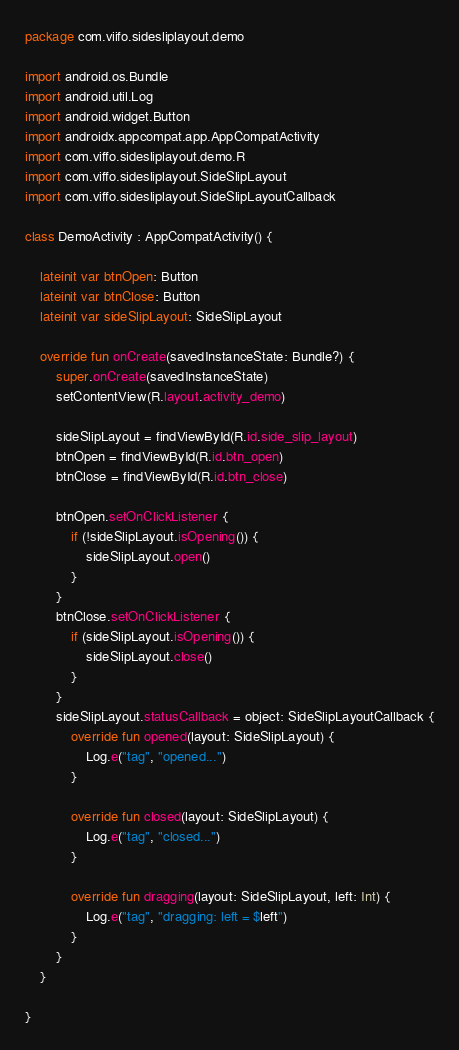<code> <loc_0><loc_0><loc_500><loc_500><_Kotlin_>package com.viifo.sidesliplayout.demo

import android.os.Bundle
import android.util.Log
import android.widget.Button
import androidx.appcompat.app.AppCompatActivity
import com.viffo.sidesliplayout.demo.R
import com.viffo.sidesliplayout.SideSlipLayout
import com.viffo.sidesliplayout.SideSlipLayoutCallback

class DemoActivity : AppCompatActivity() {

    lateinit var btnOpen: Button
    lateinit var btnClose: Button
    lateinit var sideSlipLayout: SideSlipLayout

    override fun onCreate(savedInstanceState: Bundle?) {
        super.onCreate(savedInstanceState)
        setContentView(R.layout.activity_demo)

        sideSlipLayout = findViewById(R.id.side_slip_layout)
        btnOpen = findViewById(R.id.btn_open)
        btnClose = findViewById(R.id.btn_close)

        btnOpen.setOnClickListener {
            if (!sideSlipLayout.isOpening()) {
                sideSlipLayout.open()
            }
        }
        btnClose.setOnClickListener {
            if (sideSlipLayout.isOpening()) {
                sideSlipLayout.close()
            }
        }
        sideSlipLayout.statusCallback = object: SideSlipLayoutCallback {
            override fun opened(layout: SideSlipLayout) {
                Log.e("tag", "opened...")
            }

            override fun closed(layout: SideSlipLayout) {
                Log.e("tag", "closed...")
            }

            override fun dragging(layout: SideSlipLayout, left: Int) {
                Log.e("tag", "dragging: left = $left")
            }
        }
    }

}</code> 